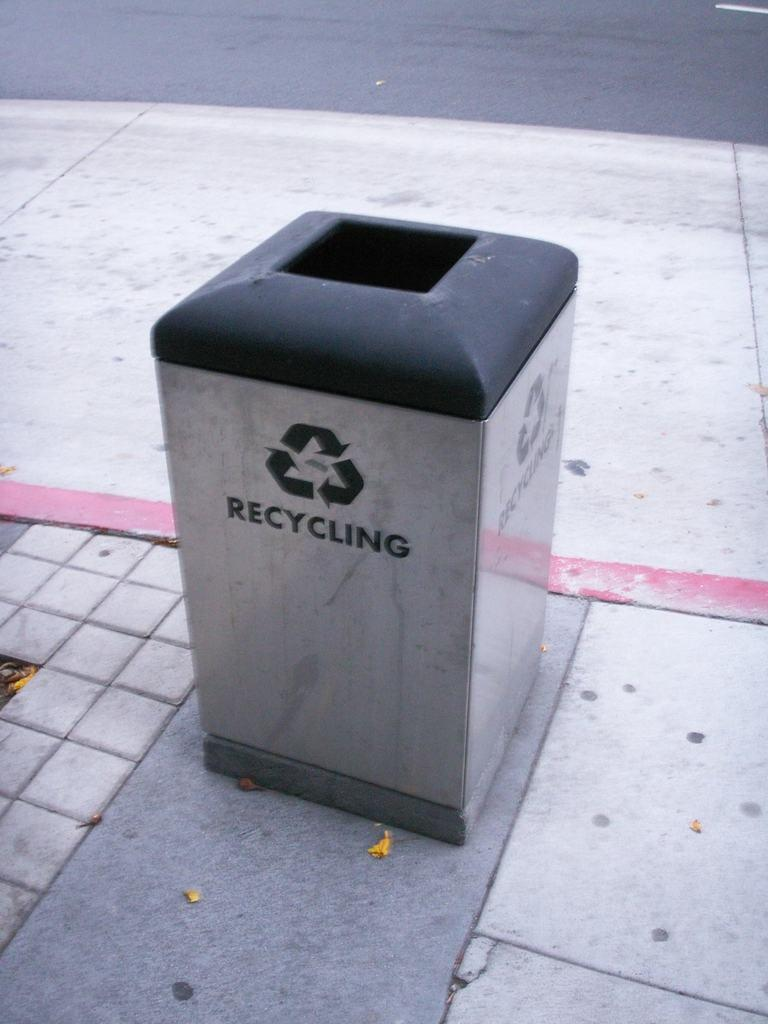Provide a one-sentence caption for the provided image. Garbage can outside which has the word RECYCLING on the front. 